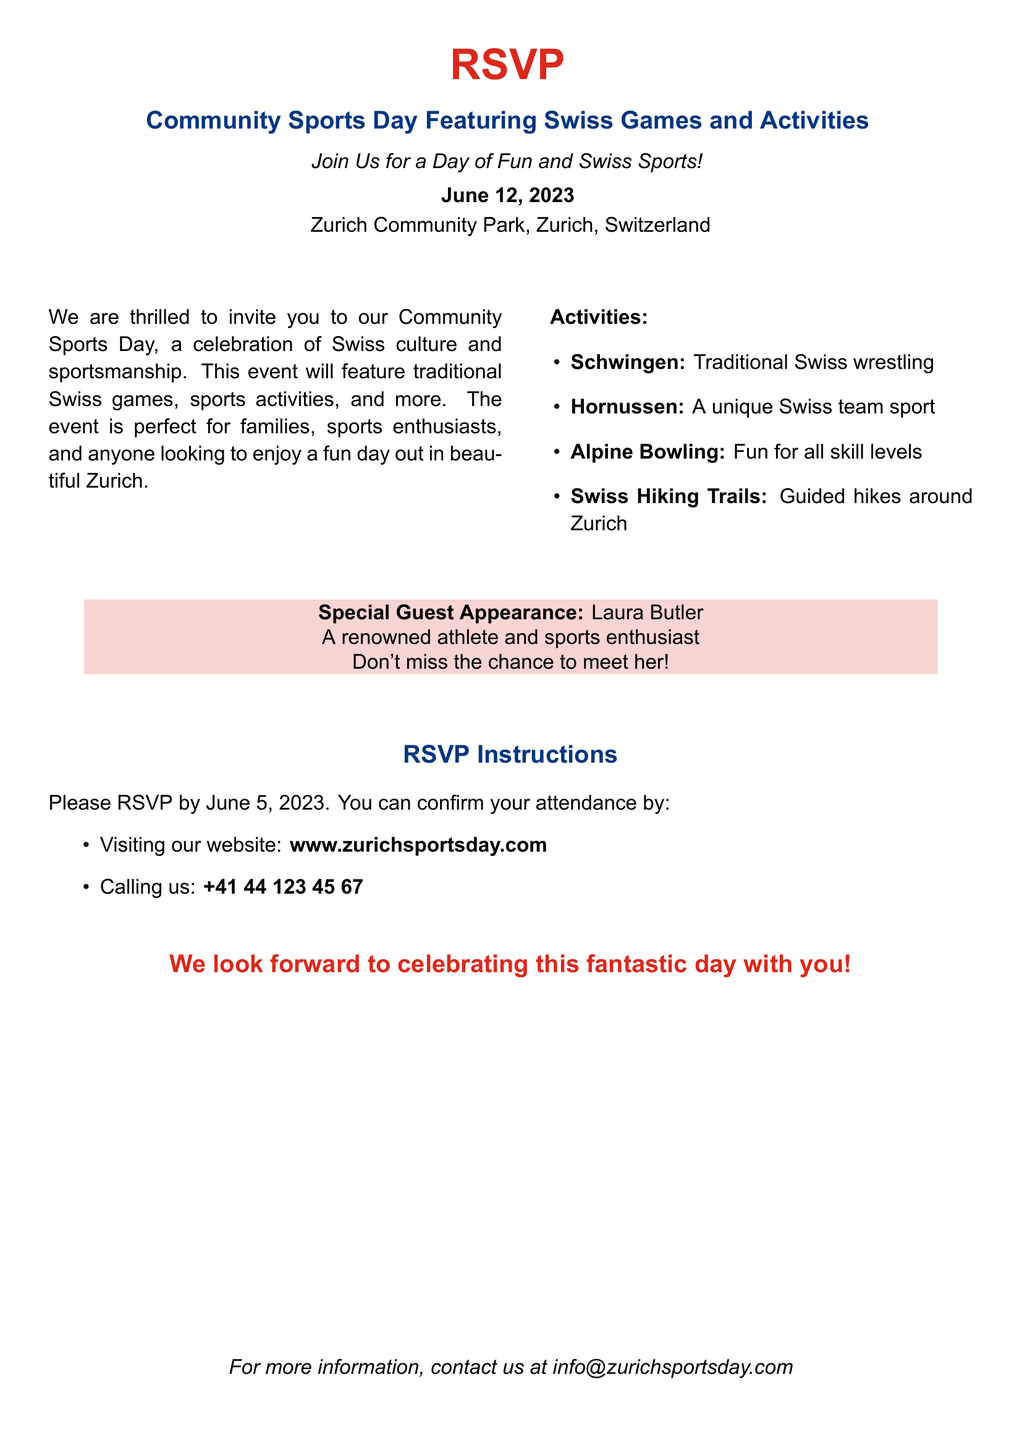What is the date of the event? The date of the Community Sports Day is specified as June 12, 2023.
Answer: June 12, 2023 Where is the event taking place? The location of the Community Sports Day is mentioned as Zurich Community Park, Zurich, Switzerland.
Answer: Zurich Community Park, Zurich, Switzerland Who is the special guest? The document states that the special guest is Laura Butler, a renowned athlete and sports enthusiast.
Answer: Laura Butler When is the RSVP deadline? The RSVP deadline is mentioned as June 5, 2023, in the document.
Answer: June 5, 2023 What is one of the activities mentioned? The document lists several activities, one of which is Schwingen, which is traditional Swiss wrestling.
Answer: Schwingen How can you confirm attendance? The document provides two methods for confirming attendance: through the website or by calling.
Answer: Website or calling What color is used for the RSVP title? The color used for the RSVP title is described as swissred in the document.
Answer: swissred Is there a contact email provided? The document mentions a contact email for more information as info@zurichsportsday.com.
Answer: info@zurichsportsday.com 